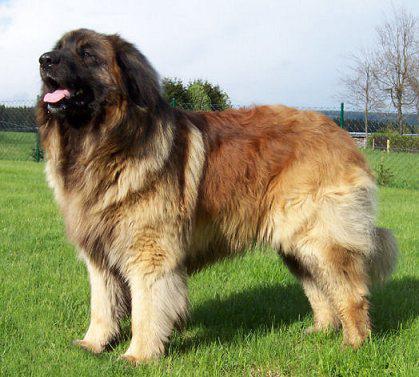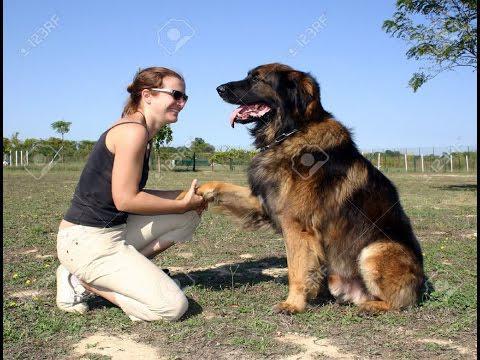The first image is the image on the left, the second image is the image on the right. For the images displayed, is the sentence "The left image contains exactly two dogs." factually correct? Answer yes or no. No. The first image is the image on the left, the second image is the image on the right. Analyze the images presented: Is the assertion "A female with bent knees is on the left of a big dog, which is the only dog in the image." valid? Answer yes or no. Yes. 